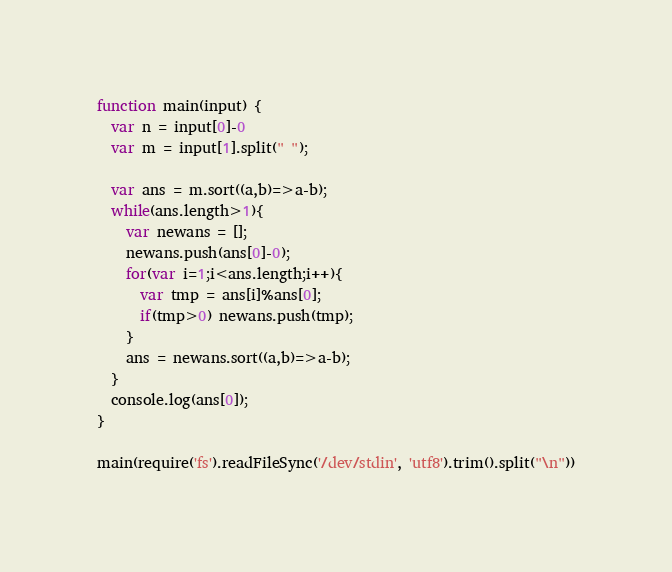<code> <loc_0><loc_0><loc_500><loc_500><_JavaScript_>function main(input) {
  var n = input[0]-0
  var m = input[1].split(" ");

  var ans = m.sort((a,b)=>a-b);
  while(ans.length>1){
    var newans = [];
    newans.push(ans[0]-0);
    for(var i=1;i<ans.length;i++){
      var tmp = ans[i]%ans[0];
      if(tmp>0) newans.push(tmp);
    }
    ans = newans.sort((a,b)=>a-b);
  }
  console.log(ans[0]);
}

main(require('fs').readFileSync('/dev/stdin', 'utf8').trim().split("\n"))
</code> 